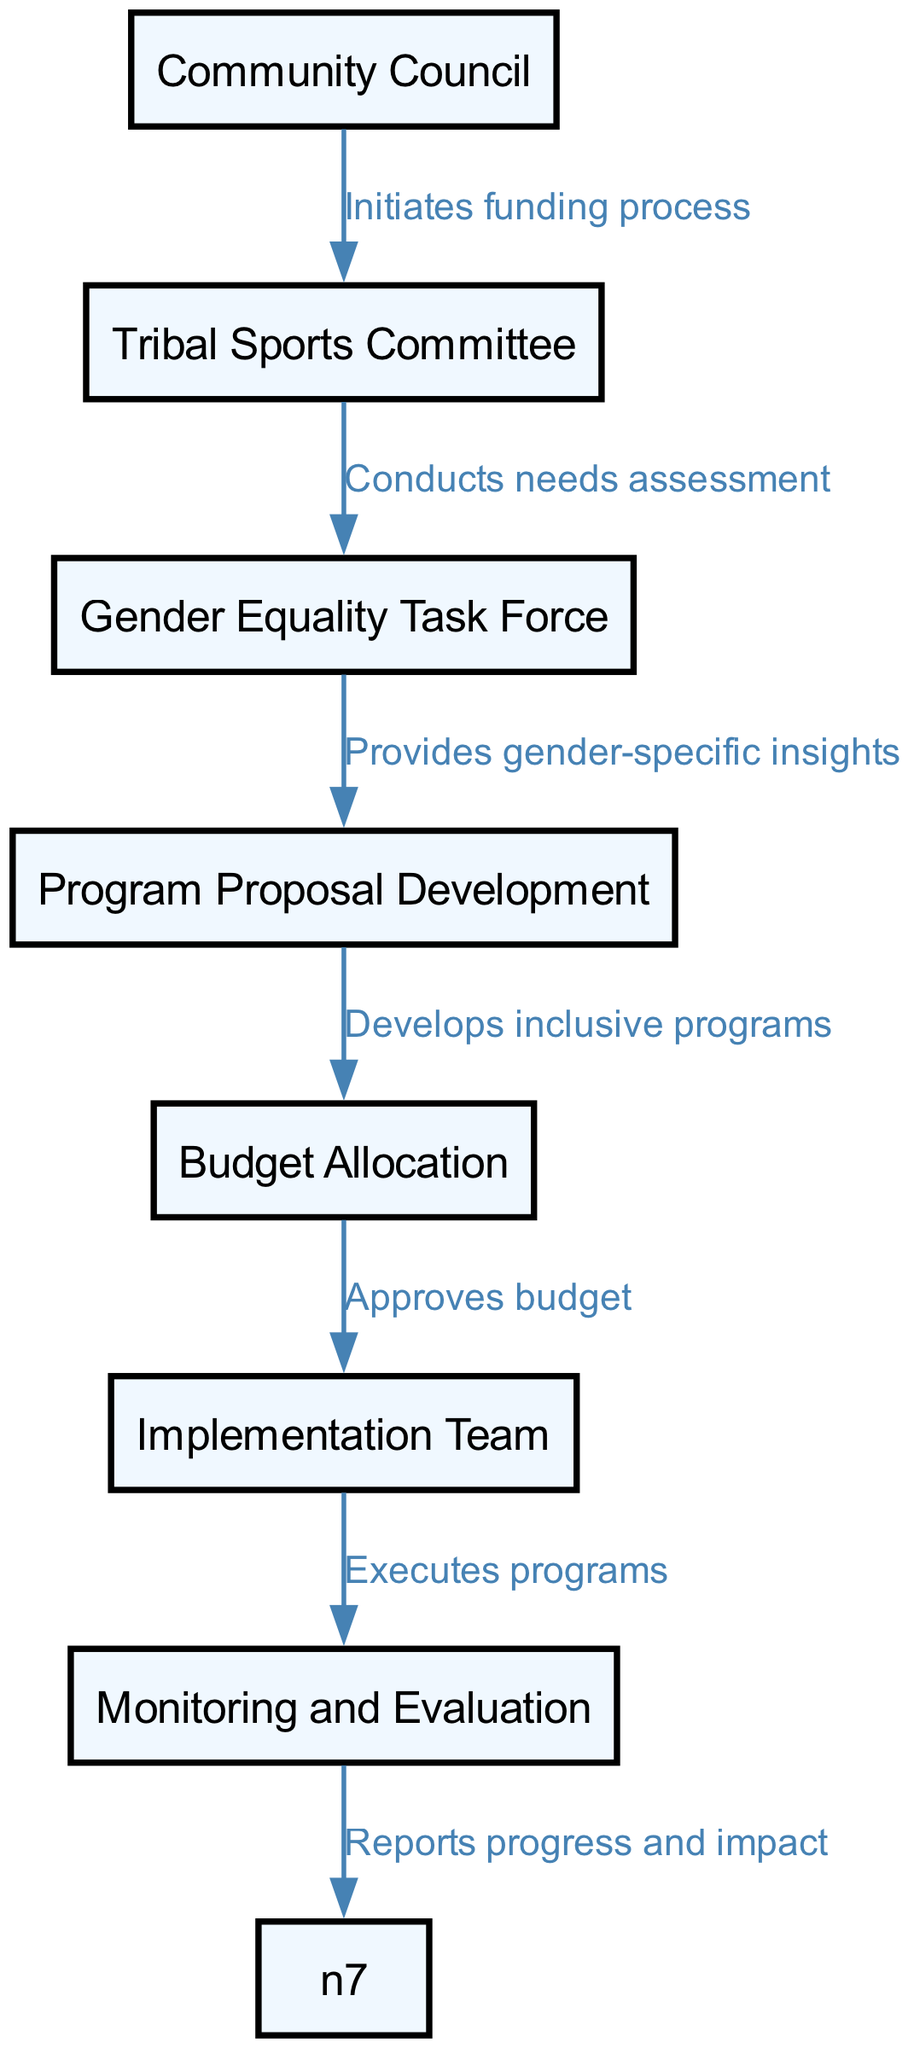What is the starting point of the funding allocation process? The diagram begins with the "Community Council" node, which indicates where the funding allocation process is initiated.
Answer: Community Council How many nodes are included in the diagram? By counting all distinct nodes listed, we find there are a total of six nodes.
Answer: 6 What is the last step in the funding allocation process? The final node in the flow of the funding allocation process is "Monitoring and Evaluation", which indicates the completion of the process.
Answer: Monitoring and Evaluation Which node directly follows "Program Proposal Development"? Looking at the connections in the diagram, "Budget Allocation" is the node that directly follows "Program Proposal Development".
Answer: Budget Allocation What relationship exists between "Tribal Sports Committee" and the "Gender Equality Task Force"? "Tribal Sports Committee" conducts a needs assessment and then provides insights to the "Gender Equality Task Force," showing a direct relationship based on their functions in the process.
Answer: Provides gender-specific insights How does the budget allocation occur according to the diagram? The flow shows that after the earlier steps, particularly after program proposals are developed, the "Budget Allocation" node is where the budget gets approved based on those proposals.
Answer: Approves budget What is the first action taken in the funding allocation process? The diagram shows that the first action taken is initiated by the "Community Council" as the starting point for the funding allocation process.
Answer: Initiates funding process Which node represents the execution of the programs? In the sequence of the flow, the node that deals with the execution of the programs is "Implementation Team" after the budget has been allocated.
Answer: Implementation Team What type of feedback mechanism is indicated in the process? The diagram includes a "Monitoring and Evaluation" stage that acts as a feedback mechanism to report on progress and impact after program implementation.
Answer: Reports progress and impact 